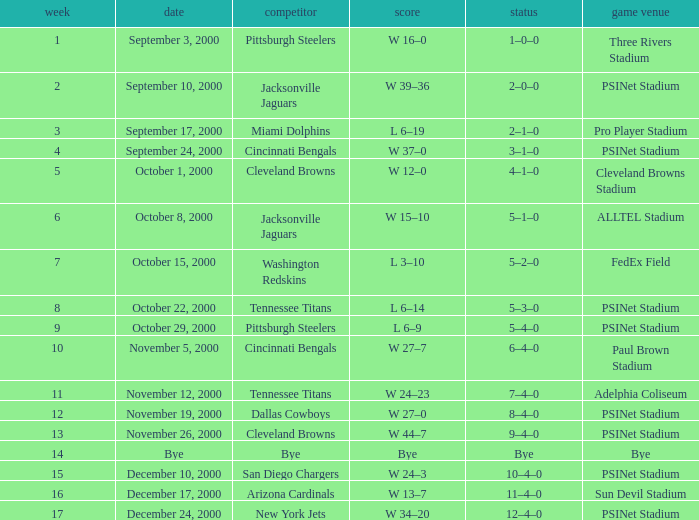What game site has a result of bye? Bye. 